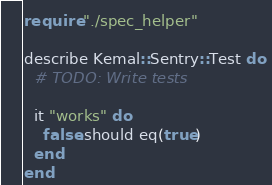<code> <loc_0><loc_0><loc_500><loc_500><_Crystal_>require "./spec_helper"

describe Kemal::Sentry::Test do
  # TODO: Write tests

  it "works" do
    false.should eq(true)
  end
end
</code> 